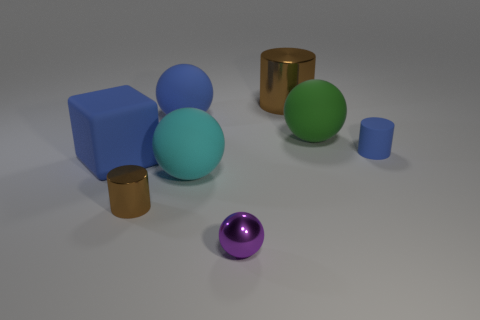There is a tiny thing right of the green ball; is its color the same as the big block?
Your response must be concise. Yes. How many things are large blue matte things that are on the left side of the small brown shiny thing or matte things that are in front of the tiny blue matte object?
Keep it short and to the point. 2. The tiny shiny thing that is in front of the tiny metallic object left of the purple object is what shape?
Offer a very short reply. Sphere. Is there any other thing that is the same color as the big cube?
Offer a very short reply. Yes. What number of objects are either green things or tiny purple things?
Offer a terse response. 2. Are there any spheres that have the same size as the rubber cylinder?
Your answer should be very brief. Yes. What shape is the small purple thing?
Give a very brief answer. Sphere. Is the number of big blue objects in front of the large green ball greater than the number of blocks that are behind the small matte cylinder?
Offer a very short reply. Yes. There is a object left of the small brown metal cylinder; is its color the same as the rubber object that is behind the green thing?
Ensure brevity in your answer.  Yes. The brown shiny thing that is the same size as the metallic sphere is what shape?
Offer a very short reply. Cylinder. 